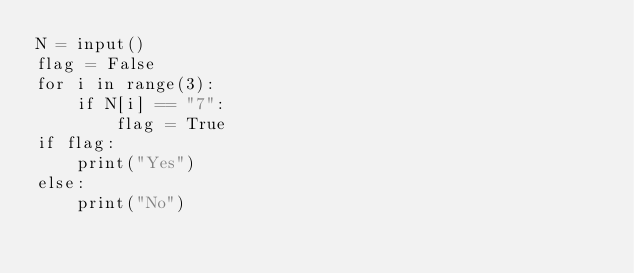Convert code to text. <code><loc_0><loc_0><loc_500><loc_500><_Python_>N = input()
flag = False
for i in range(3):
    if N[i] == "7":
        flag = True
if flag:
    print("Yes")
else:
    print("No")
</code> 